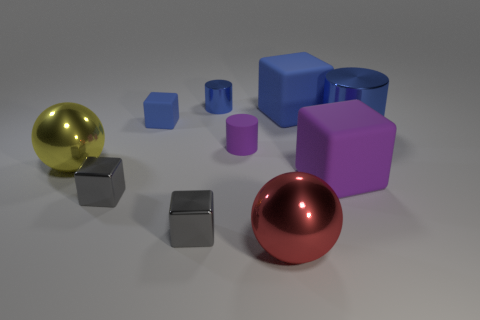Subtract all spheres. How many objects are left? 8 Add 5 large blue matte things. How many large blue matte things are left? 6 Add 8 tiny blue shiny cylinders. How many tiny blue shiny cylinders exist? 9 Subtract 0 green cylinders. How many objects are left? 10 Subtract all small blue matte blocks. Subtract all cubes. How many objects are left? 4 